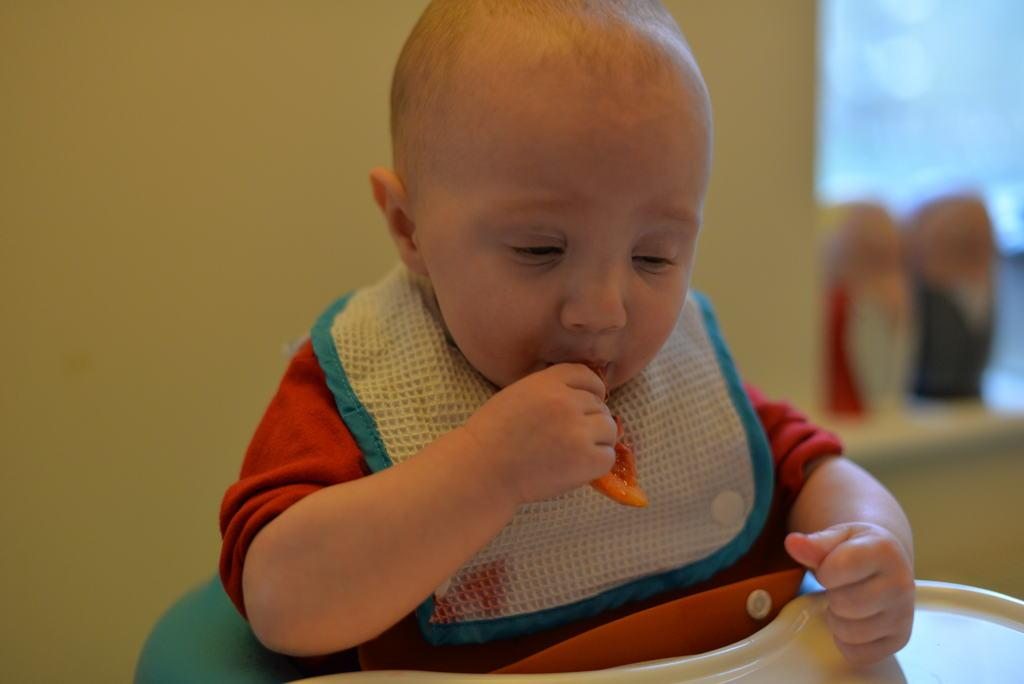What is the main subject of the image? There is a baby in the image. What is the baby doing in the image? The baby is seated on a babysitter and holding food in their hand. What can be seen in the background of the image? There is a wall visible in the background of the image. What type of discussion is taking place between the baby and the babysitter in the image? There is no discussion taking place between the baby and the babysitter in the image. Can you see the baby smiling in the image? The provided facts do not mention the baby's facial expression, so it cannot be determined if the baby is smiling. 